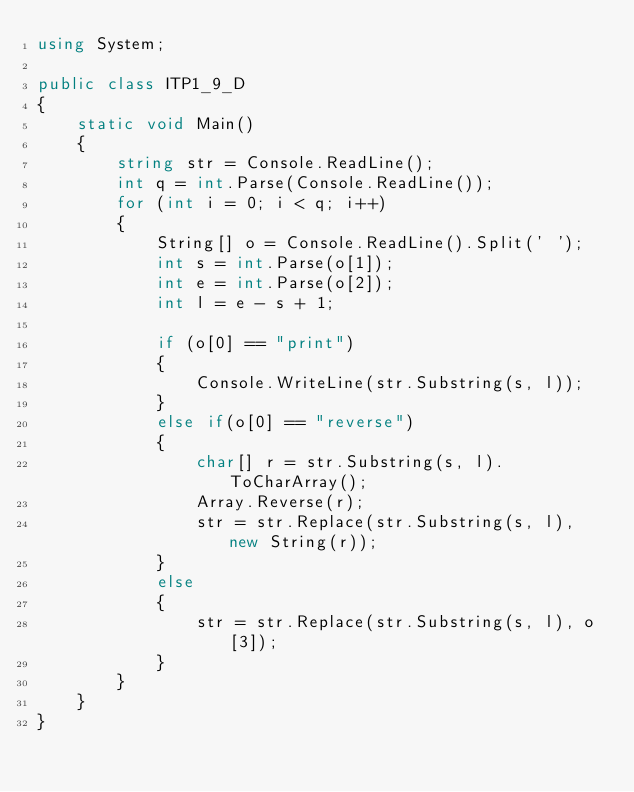<code> <loc_0><loc_0><loc_500><loc_500><_C#_>using System;

public class ITP1_9_D
{
    static void Main()
    {
        string str = Console.ReadLine();
        int q = int.Parse(Console.ReadLine());
        for (int i = 0; i < q; i++)
        {
            String[] o = Console.ReadLine().Split(' ');
            int s = int.Parse(o[1]);
            int e = int.Parse(o[2]);
            int l = e - s + 1;

            if (o[0] == "print")
            {
                Console.WriteLine(str.Substring(s, l));
            }
            else if(o[0] == "reverse")
            {
                char[] r = str.Substring(s, l).ToCharArray();
                Array.Reverse(r);
                str = str.Replace(str.Substring(s, l), new String(r));
            }
            else
            {
                str = str.Replace(str.Substring(s, l), o[3]);
            }
        }
    }
}</code> 